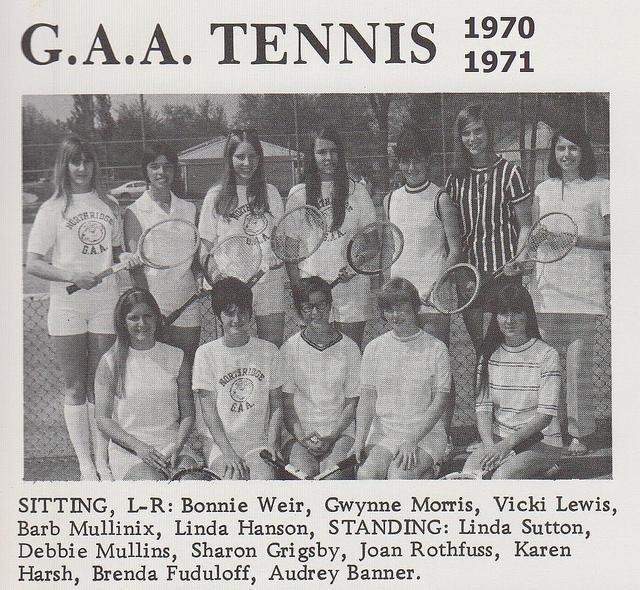How many people are there?
Give a very brief answer. 11. How many tennis rackets are there?
Give a very brief answer. 2. How many orange buttons on the toilet?
Give a very brief answer. 0. 